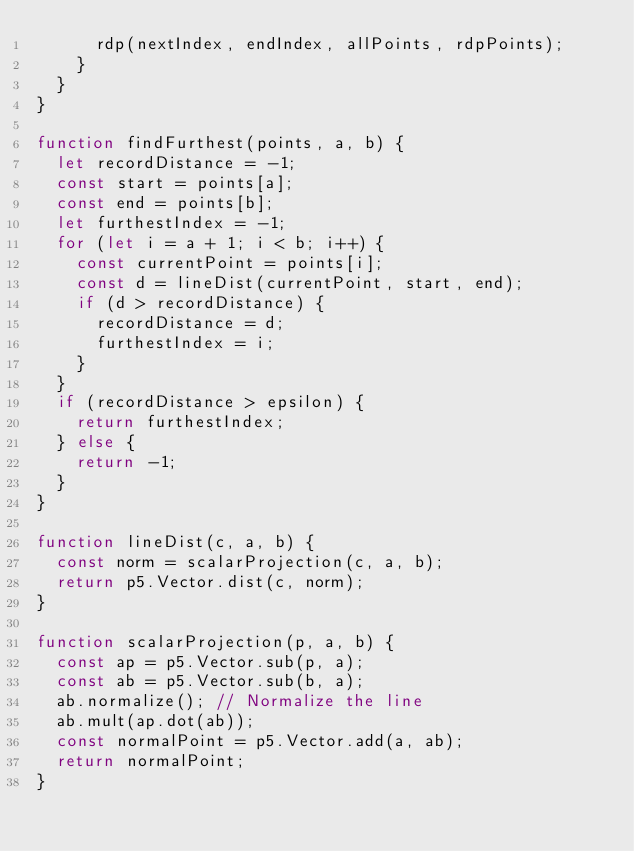<code> <loc_0><loc_0><loc_500><loc_500><_JavaScript_>      rdp(nextIndex, endIndex, allPoints, rdpPoints);
    }
  }
}

function findFurthest(points, a, b) {
  let recordDistance = -1;
  const start = points[a];
  const end = points[b];
  let furthestIndex = -1;
  for (let i = a + 1; i < b; i++) {
    const currentPoint = points[i];
    const d = lineDist(currentPoint, start, end);
    if (d > recordDistance) {
      recordDistance = d;
      furthestIndex = i;
    }
  }
  if (recordDistance > epsilon) {
    return furthestIndex;
  } else {
    return -1;
  }
}

function lineDist(c, a, b) {
  const norm = scalarProjection(c, a, b);
  return p5.Vector.dist(c, norm);
}

function scalarProjection(p, a, b) {
  const ap = p5.Vector.sub(p, a);
  const ab = p5.Vector.sub(b, a);
  ab.normalize(); // Normalize the line
  ab.mult(ap.dot(ab));
  const normalPoint = p5.Vector.add(a, ab);
  return normalPoint;
}
</code> 